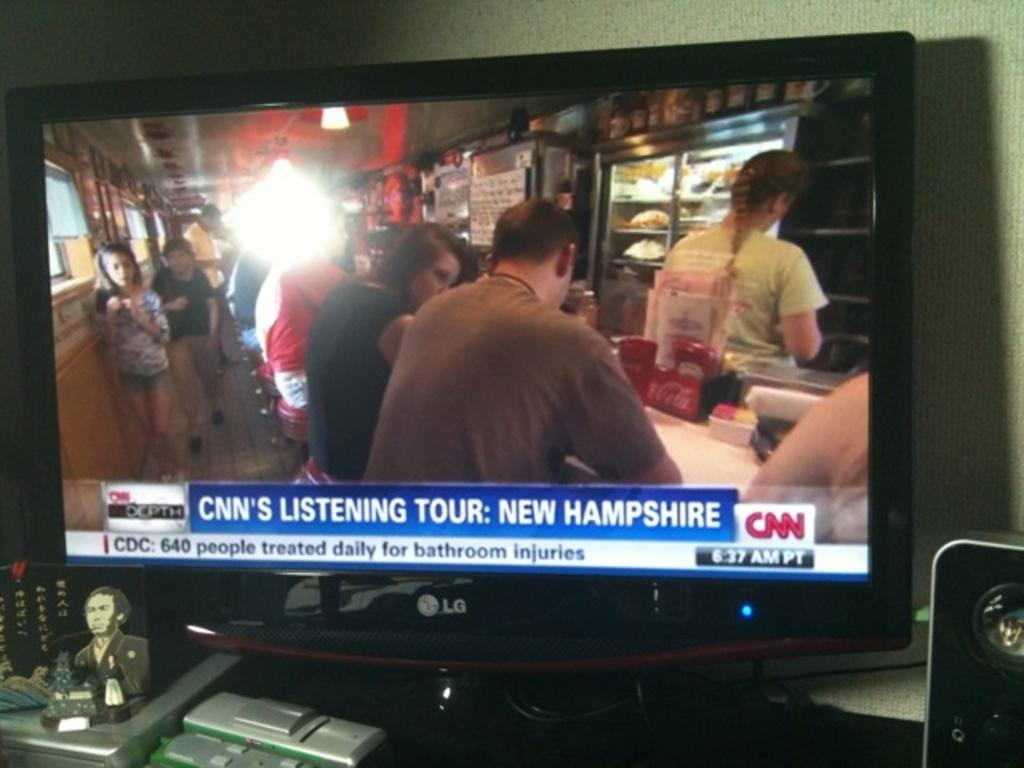Provide a one-sentence caption for the provided image. A tv screen showing a CNN's listening tour broadcast. 